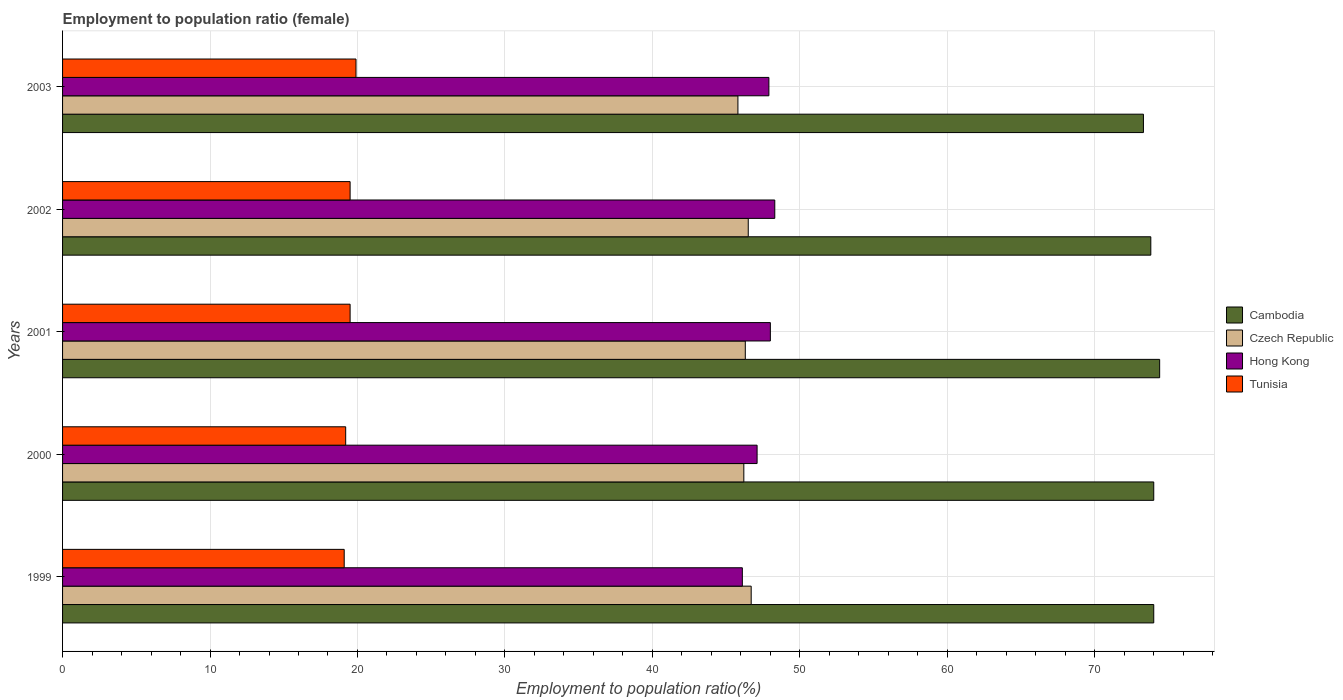How many different coloured bars are there?
Ensure brevity in your answer.  4. How many groups of bars are there?
Ensure brevity in your answer.  5. Are the number of bars per tick equal to the number of legend labels?
Provide a succinct answer. Yes. How many bars are there on the 3rd tick from the top?
Offer a very short reply. 4. In how many cases, is the number of bars for a given year not equal to the number of legend labels?
Offer a terse response. 0. What is the employment to population ratio in Czech Republic in 2000?
Make the answer very short. 46.2. Across all years, what is the maximum employment to population ratio in Tunisia?
Give a very brief answer. 19.9. Across all years, what is the minimum employment to population ratio in Hong Kong?
Ensure brevity in your answer.  46.1. What is the total employment to population ratio in Hong Kong in the graph?
Ensure brevity in your answer.  237.4. What is the difference between the employment to population ratio in Hong Kong in 2002 and that in 2003?
Ensure brevity in your answer.  0.4. What is the difference between the employment to population ratio in Cambodia in 2000 and the employment to population ratio in Czech Republic in 2003?
Your response must be concise. 28.2. What is the average employment to population ratio in Cambodia per year?
Your response must be concise. 73.9. In the year 2000, what is the difference between the employment to population ratio in Tunisia and employment to population ratio in Hong Kong?
Your response must be concise. -27.9. In how many years, is the employment to population ratio in Hong Kong greater than 12 %?
Your answer should be compact. 5. Is the employment to population ratio in Czech Republic in 2002 less than that in 2003?
Ensure brevity in your answer.  No. Is the difference between the employment to population ratio in Tunisia in 1999 and 2001 greater than the difference between the employment to population ratio in Hong Kong in 1999 and 2001?
Your response must be concise. Yes. What is the difference between the highest and the second highest employment to population ratio in Hong Kong?
Offer a very short reply. 0.3. What is the difference between the highest and the lowest employment to population ratio in Hong Kong?
Provide a succinct answer. 2.2. In how many years, is the employment to population ratio in Hong Kong greater than the average employment to population ratio in Hong Kong taken over all years?
Provide a succinct answer. 3. Is it the case that in every year, the sum of the employment to population ratio in Hong Kong and employment to population ratio in Tunisia is greater than the sum of employment to population ratio in Cambodia and employment to population ratio in Czech Republic?
Provide a short and direct response. No. What does the 1st bar from the top in 2002 represents?
Your answer should be compact. Tunisia. What does the 3rd bar from the bottom in 2001 represents?
Your answer should be very brief. Hong Kong. Are all the bars in the graph horizontal?
Ensure brevity in your answer.  Yes. How many years are there in the graph?
Offer a terse response. 5. Are the values on the major ticks of X-axis written in scientific E-notation?
Make the answer very short. No. Does the graph contain grids?
Offer a terse response. Yes. Where does the legend appear in the graph?
Give a very brief answer. Center right. What is the title of the graph?
Your answer should be compact. Employment to population ratio (female). Does "Cyprus" appear as one of the legend labels in the graph?
Offer a very short reply. No. What is the label or title of the X-axis?
Make the answer very short. Employment to population ratio(%). What is the Employment to population ratio(%) of Cambodia in 1999?
Ensure brevity in your answer.  74. What is the Employment to population ratio(%) in Czech Republic in 1999?
Provide a short and direct response. 46.7. What is the Employment to population ratio(%) in Hong Kong in 1999?
Your answer should be very brief. 46.1. What is the Employment to population ratio(%) of Tunisia in 1999?
Give a very brief answer. 19.1. What is the Employment to population ratio(%) in Czech Republic in 2000?
Ensure brevity in your answer.  46.2. What is the Employment to population ratio(%) of Hong Kong in 2000?
Give a very brief answer. 47.1. What is the Employment to population ratio(%) of Tunisia in 2000?
Your answer should be very brief. 19.2. What is the Employment to population ratio(%) in Cambodia in 2001?
Ensure brevity in your answer.  74.4. What is the Employment to population ratio(%) in Czech Republic in 2001?
Your response must be concise. 46.3. What is the Employment to population ratio(%) in Hong Kong in 2001?
Ensure brevity in your answer.  48. What is the Employment to population ratio(%) of Cambodia in 2002?
Offer a terse response. 73.8. What is the Employment to population ratio(%) of Czech Republic in 2002?
Provide a short and direct response. 46.5. What is the Employment to population ratio(%) of Hong Kong in 2002?
Offer a terse response. 48.3. What is the Employment to population ratio(%) in Cambodia in 2003?
Offer a very short reply. 73.3. What is the Employment to population ratio(%) in Czech Republic in 2003?
Make the answer very short. 45.8. What is the Employment to population ratio(%) in Hong Kong in 2003?
Your answer should be very brief. 47.9. What is the Employment to population ratio(%) of Tunisia in 2003?
Offer a very short reply. 19.9. Across all years, what is the maximum Employment to population ratio(%) in Cambodia?
Make the answer very short. 74.4. Across all years, what is the maximum Employment to population ratio(%) of Czech Republic?
Your response must be concise. 46.7. Across all years, what is the maximum Employment to population ratio(%) of Hong Kong?
Provide a short and direct response. 48.3. Across all years, what is the maximum Employment to population ratio(%) of Tunisia?
Give a very brief answer. 19.9. Across all years, what is the minimum Employment to population ratio(%) of Cambodia?
Provide a succinct answer. 73.3. Across all years, what is the minimum Employment to population ratio(%) of Czech Republic?
Your answer should be very brief. 45.8. Across all years, what is the minimum Employment to population ratio(%) in Hong Kong?
Give a very brief answer. 46.1. Across all years, what is the minimum Employment to population ratio(%) in Tunisia?
Give a very brief answer. 19.1. What is the total Employment to population ratio(%) of Cambodia in the graph?
Make the answer very short. 369.5. What is the total Employment to population ratio(%) in Czech Republic in the graph?
Offer a terse response. 231.5. What is the total Employment to population ratio(%) in Hong Kong in the graph?
Provide a succinct answer. 237.4. What is the total Employment to population ratio(%) of Tunisia in the graph?
Your answer should be compact. 97.2. What is the difference between the Employment to population ratio(%) of Czech Republic in 1999 and that in 2000?
Provide a succinct answer. 0.5. What is the difference between the Employment to population ratio(%) of Hong Kong in 1999 and that in 2000?
Keep it short and to the point. -1. What is the difference between the Employment to population ratio(%) of Cambodia in 1999 and that in 2001?
Your answer should be compact. -0.4. What is the difference between the Employment to population ratio(%) in Czech Republic in 1999 and that in 2001?
Your answer should be very brief. 0.4. What is the difference between the Employment to population ratio(%) in Tunisia in 1999 and that in 2001?
Offer a very short reply. -0.4. What is the difference between the Employment to population ratio(%) of Cambodia in 1999 and that in 2002?
Keep it short and to the point. 0.2. What is the difference between the Employment to population ratio(%) of Hong Kong in 1999 and that in 2002?
Keep it short and to the point. -2.2. What is the difference between the Employment to population ratio(%) in Hong Kong in 1999 and that in 2003?
Your answer should be compact. -1.8. What is the difference between the Employment to population ratio(%) of Cambodia in 2000 and that in 2001?
Make the answer very short. -0.4. What is the difference between the Employment to population ratio(%) of Hong Kong in 2000 and that in 2001?
Your answer should be very brief. -0.9. What is the difference between the Employment to population ratio(%) of Czech Republic in 2000 and that in 2002?
Your answer should be very brief. -0.3. What is the difference between the Employment to population ratio(%) of Hong Kong in 2000 and that in 2002?
Ensure brevity in your answer.  -1.2. What is the difference between the Employment to population ratio(%) of Tunisia in 2000 and that in 2002?
Your response must be concise. -0.3. What is the difference between the Employment to population ratio(%) in Cambodia in 2000 and that in 2003?
Make the answer very short. 0.7. What is the difference between the Employment to population ratio(%) of Hong Kong in 2000 and that in 2003?
Your answer should be very brief. -0.8. What is the difference between the Employment to population ratio(%) in Tunisia in 2000 and that in 2003?
Your response must be concise. -0.7. What is the difference between the Employment to population ratio(%) of Cambodia in 2001 and that in 2002?
Your answer should be compact. 0.6. What is the difference between the Employment to population ratio(%) in Hong Kong in 2001 and that in 2002?
Your response must be concise. -0.3. What is the difference between the Employment to population ratio(%) in Tunisia in 2001 and that in 2002?
Keep it short and to the point. 0. What is the difference between the Employment to population ratio(%) of Cambodia in 2001 and that in 2003?
Offer a very short reply. 1.1. What is the difference between the Employment to population ratio(%) of Czech Republic in 2001 and that in 2003?
Offer a terse response. 0.5. What is the difference between the Employment to population ratio(%) of Cambodia in 1999 and the Employment to population ratio(%) of Czech Republic in 2000?
Offer a terse response. 27.8. What is the difference between the Employment to population ratio(%) of Cambodia in 1999 and the Employment to population ratio(%) of Hong Kong in 2000?
Your response must be concise. 26.9. What is the difference between the Employment to population ratio(%) of Cambodia in 1999 and the Employment to population ratio(%) of Tunisia in 2000?
Give a very brief answer. 54.8. What is the difference between the Employment to population ratio(%) of Czech Republic in 1999 and the Employment to population ratio(%) of Hong Kong in 2000?
Give a very brief answer. -0.4. What is the difference between the Employment to population ratio(%) of Czech Republic in 1999 and the Employment to population ratio(%) of Tunisia in 2000?
Your answer should be very brief. 27.5. What is the difference between the Employment to population ratio(%) in Hong Kong in 1999 and the Employment to population ratio(%) in Tunisia in 2000?
Provide a succinct answer. 26.9. What is the difference between the Employment to population ratio(%) of Cambodia in 1999 and the Employment to population ratio(%) of Czech Republic in 2001?
Your answer should be compact. 27.7. What is the difference between the Employment to population ratio(%) of Cambodia in 1999 and the Employment to population ratio(%) of Hong Kong in 2001?
Offer a terse response. 26. What is the difference between the Employment to population ratio(%) in Cambodia in 1999 and the Employment to population ratio(%) in Tunisia in 2001?
Make the answer very short. 54.5. What is the difference between the Employment to population ratio(%) of Czech Republic in 1999 and the Employment to population ratio(%) of Tunisia in 2001?
Offer a terse response. 27.2. What is the difference between the Employment to population ratio(%) in Hong Kong in 1999 and the Employment to population ratio(%) in Tunisia in 2001?
Make the answer very short. 26.6. What is the difference between the Employment to population ratio(%) in Cambodia in 1999 and the Employment to population ratio(%) in Hong Kong in 2002?
Make the answer very short. 25.7. What is the difference between the Employment to population ratio(%) in Cambodia in 1999 and the Employment to population ratio(%) in Tunisia in 2002?
Give a very brief answer. 54.5. What is the difference between the Employment to population ratio(%) of Czech Republic in 1999 and the Employment to population ratio(%) of Hong Kong in 2002?
Offer a terse response. -1.6. What is the difference between the Employment to population ratio(%) in Czech Republic in 1999 and the Employment to population ratio(%) in Tunisia in 2002?
Offer a very short reply. 27.2. What is the difference between the Employment to population ratio(%) in Hong Kong in 1999 and the Employment to population ratio(%) in Tunisia in 2002?
Offer a very short reply. 26.6. What is the difference between the Employment to population ratio(%) in Cambodia in 1999 and the Employment to population ratio(%) in Czech Republic in 2003?
Ensure brevity in your answer.  28.2. What is the difference between the Employment to population ratio(%) of Cambodia in 1999 and the Employment to population ratio(%) of Hong Kong in 2003?
Provide a succinct answer. 26.1. What is the difference between the Employment to population ratio(%) of Cambodia in 1999 and the Employment to population ratio(%) of Tunisia in 2003?
Provide a succinct answer. 54.1. What is the difference between the Employment to population ratio(%) of Czech Republic in 1999 and the Employment to population ratio(%) of Hong Kong in 2003?
Provide a succinct answer. -1.2. What is the difference between the Employment to population ratio(%) of Czech Republic in 1999 and the Employment to population ratio(%) of Tunisia in 2003?
Offer a terse response. 26.8. What is the difference between the Employment to population ratio(%) in Hong Kong in 1999 and the Employment to population ratio(%) in Tunisia in 2003?
Your answer should be compact. 26.2. What is the difference between the Employment to population ratio(%) of Cambodia in 2000 and the Employment to population ratio(%) of Czech Republic in 2001?
Your answer should be very brief. 27.7. What is the difference between the Employment to population ratio(%) of Cambodia in 2000 and the Employment to population ratio(%) of Tunisia in 2001?
Make the answer very short. 54.5. What is the difference between the Employment to population ratio(%) in Czech Republic in 2000 and the Employment to population ratio(%) in Hong Kong in 2001?
Provide a short and direct response. -1.8. What is the difference between the Employment to population ratio(%) in Czech Republic in 2000 and the Employment to population ratio(%) in Tunisia in 2001?
Your response must be concise. 26.7. What is the difference between the Employment to population ratio(%) of Hong Kong in 2000 and the Employment to population ratio(%) of Tunisia in 2001?
Your answer should be compact. 27.6. What is the difference between the Employment to population ratio(%) in Cambodia in 2000 and the Employment to population ratio(%) in Hong Kong in 2002?
Offer a very short reply. 25.7. What is the difference between the Employment to population ratio(%) of Cambodia in 2000 and the Employment to population ratio(%) of Tunisia in 2002?
Offer a very short reply. 54.5. What is the difference between the Employment to population ratio(%) in Czech Republic in 2000 and the Employment to population ratio(%) in Hong Kong in 2002?
Provide a succinct answer. -2.1. What is the difference between the Employment to population ratio(%) in Czech Republic in 2000 and the Employment to population ratio(%) in Tunisia in 2002?
Keep it short and to the point. 26.7. What is the difference between the Employment to population ratio(%) in Hong Kong in 2000 and the Employment to population ratio(%) in Tunisia in 2002?
Keep it short and to the point. 27.6. What is the difference between the Employment to population ratio(%) of Cambodia in 2000 and the Employment to population ratio(%) of Czech Republic in 2003?
Offer a very short reply. 28.2. What is the difference between the Employment to population ratio(%) in Cambodia in 2000 and the Employment to population ratio(%) in Hong Kong in 2003?
Your answer should be compact. 26.1. What is the difference between the Employment to population ratio(%) of Cambodia in 2000 and the Employment to population ratio(%) of Tunisia in 2003?
Your response must be concise. 54.1. What is the difference between the Employment to population ratio(%) of Czech Republic in 2000 and the Employment to population ratio(%) of Tunisia in 2003?
Your response must be concise. 26.3. What is the difference between the Employment to population ratio(%) in Hong Kong in 2000 and the Employment to population ratio(%) in Tunisia in 2003?
Ensure brevity in your answer.  27.2. What is the difference between the Employment to population ratio(%) of Cambodia in 2001 and the Employment to population ratio(%) of Czech Republic in 2002?
Ensure brevity in your answer.  27.9. What is the difference between the Employment to population ratio(%) in Cambodia in 2001 and the Employment to population ratio(%) in Hong Kong in 2002?
Offer a very short reply. 26.1. What is the difference between the Employment to population ratio(%) in Cambodia in 2001 and the Employment to population ratio(%) in Tunisia in 2002?
Make the answer very short. 54.9. What is the difference between the Employment to population ratio(%) of Czech Republic in 2001 and the Employment to population ratio(%) of Tunisia in 2002?
Provide a succinct answer. 26.8. What is the difference between the Employment to population ratio(%) of Hong Kong in 2001 and the Employment to population ratio(%) of Tunisia in 2002?
Offer a terse response. 28.5. What is the difference between the Employment to population ratio(%) of Cambodia in 2001 and the Employment to population ratio(%) of Czech Republic in 2003?
Provide a succinct answer. 28.6. What is the difference between the Employment to population ratio(%) of Cambodia in 2001 and the Employment to population ratio(%) of Tunisia in 2003?
Your answer should be very brief. 54.5. What is the difference between the Employment to population ratio(%) of Czech Republic in 2001 and the Employment to population ratio(%) of Tunisia in 2003?
Provide a short and direct response. 26.4. What is the difference between the Employment to population ratio(%) in Hong Kong in 2001 and the Employment to population ratio(%) in Tunisia in 2003?
Ensure brevity in your answer.  28.1. What is the difference between the Employment to population ratio(%) in Cambodia in 2002 and the Employment to population ratio(%) in Hong Kong in 2003?
Give a very brief answer. 25.9. What is the difference between the Employment to population ratio(%) of Cambodia in 2002 and the Employment to population ratio(%) of Tunisia in 2003?
Keep it short and to the point. 53.9. What is the difference between the Employment to population ratio(%) in Czech Republic in 2002 and the Employment to population ratio(%) in Tunisia in 2003?
Provide a succinct answer. 26.6. What is the difference between the Employment to population ratio(%) in Hong Kong in 2002 and the Employment to population ratio(%) in Tunisia in 2003?
Give a very brief answer. 28.4. What is the average Employment to population ratio(%) of Cambodia per year?
Provide a succinct answer. 73.9. What is the average Employment to population ratio(%) in Czech Republic per year?
Provide a succinct answer. 46.3. What is the average Employment to population ratio(%) in Hong Kong per year?
Give a very brief answer. 47.48. What is the average Employment to population ratio(%) of Tunisia per year?
Your answer should be compact. 19.44. In the year 1999, what is the difference between the Employment to population ratio(%) of Cambodia and Employment to population ratio(%) of Czech Republic?
Your answer should be compact. 27.3. In the year 1999, what is the difference between the Employment to population ratio(%) of Cambodia and Employment to population ratio(%) of Hong Kong?
Offer a very short reply. 27.9. In the year 1999, what is the difference between the Employment to population ratio(%) in Cambodia and Employment to population ratio(%) in Tunisia?
Give a very brief answer. 54.9. In the year 1999, what is the difference between the Employment to population ratio(%) in Czech Republic and Employment to population ratio(%) in Hong Kong?
Provide a short and direct response. 0.6. In the year 1999, what is the difference between the Employment to population ratio(%) of Czech Republic and Employment to population ratio(%) of Tunisia?
Your answer should be very brief. 27.6. In the year 2000, what is the difference between the Employment to population ratio(%) of Cambodia and Employment to population ratio(%) of Czech Republic?
Provide a short and direct response. 27.8. In the year 2000, what is the difference between the Employment to population ratio(%) of Cambodia and Employment to population ratio(%) of Hong Kong?
Ensure brevity in your answer.  26.9. In the year 2000, what is the difference between the Employment to population ratio(%) of Cambodia and Employment to population ratio(%) of Tunisia?
Provide a succinct answer. 54.8. In the year 2000, what is the difference between the Employment to population ratio(%) in Czech Republic and Employment to population ratio(%) in Hong Kong?
Offer a terse response. -0.9. In the year 2000, what is the difference between the Employment to population ratio(%) in Hong Kong and Employment to population ratio(%) in Tunisia?
Your answer should be compact. 27.9. In the year 2001, what is the difference between the Employment to population ratio(%) of Cambodia and Employment to population ratio(%) of Czech Republic?
Offer a very short reply. 28.1. In the year 2001, what is the difference between the Employment to population ratio(%) of Cambodia and Employment to population ratio(%) of Hong Kong?
Provide a short and direct response. 26.4. In the year 2001, what is the difference between the Employment to population ratio(%) in Cambodia and Employment to population ratio(%) in Tunisia?
Your answer should be very brief. 54.9. In the year 2001, what is the difference between the Employment to population ratio(%) of Czech Republic and Employment to population ratio(%) of Hong Kong?
Your answer should be very brief. -1.7. In the year 2001, what is the difference between the Employment to population ratio(%) in Czech Republic and Employment to population ratio(%) in Tunisia?
Make the answer very short. 26.8. In the year 2001, what is the difference between the Employment to population ratio(%) of Hong Kong and Employment to population ratio(%) of Tunisia?
Make the answer very short. 28.5. In the year 2002, what is the difference between the Employment to population ratio(%) of Cambodia and Employment to population ratio(%) of Czech Republic?
Your response must be concise. 27.3. In the year 2002, what is the difference between the Employment to population ratio(%) of Cambodia and Employment to population ratio(%) of Tunisia?
Provide a short and direct response. 54.3. In the year 2002, what is the difference between the Employment to population ratio(%) in Hong Kong and Employment to population ratio(%) in Tunisia?
Offer a very short reply. 28.8. In the year 2003, what is the difference between the Employment to population ratio(%) in Cambodia and Employment to population ratio(%) in Hong Kong?
Make the answer very short. 25.4. In the year 2003, what is the difference between the Employment to population ratio(%) in Cambodia and Employment to population ratio(%) in Tunisia?
Offer a very short reply. 53.4. In the year 2003, what is the difference between the Employment to population ratio(%) in Czech Republic and Employment to population ratio(%) in Hong Kong?
Your response must be concise. -2.1. In the year 2003, what is the difference between the Employment to population ratio(%) of Czech Republic and Employment to population ratio(%) of Tunisia?
Your response must be concise. 25.9. What is the ratio of the Employment to population ratio(%) of Czech Republic in 1999 to that in 2000?
Offer a very short reply. 1.01. What is the ratio of the Employment to population ratio(%) in Hong Kong in 1999 to that in 2000?
Give a very brief answer. 0.98. What is the ratio of the Employment to population ratio(%) of Czech Republic in 1999 to that in 2001?
Keep it short and to the point. 1.01. What is the ratio of the Employment to population ratio(%) of Hong Kong in 1999 to that in 2001?
Give a very brief answer. 0.96. What is the ratio of the Employment to population ratio(%) of Tunisia in 1999 to that in 2001?
Your answer should be compact. 0.98. What is the ratio of the Employment to population ratio(%) in Czech Republic in 1999 to that in 2002?
Provide a short and direct response. 1. What is the ratio of the Employment to population ratio(%) of Hong Kong in 1999 to that in 2002?
Offer a very short reply. 0.95. What is the ratio of the Employment to population ratio(%) in Tunisia in 1999 to that in 2002?
Your answer should be compact. 0.98. What is the ratio of the Employment to population ratio(%) in Cambodia in 1999 to that in 2003?
Offer a terse response. 1.01. What is the ratio of the Employment to population ratio(%) of Czech Republic in 1999 to that in 2003?
Your answer should be compact. 1.02. What is the ratio of the Employment to population ratio(%) of Hong Kong in 1999 to that in 2003?
Ensure brevity in your answer.  0.96. What is the ratio of the Employment to population ratio(%) of Tunisia in 1999 to that in 2003?
Provide a succinct answer. 0.96. What is the ratio of the Employment to population ratio(%) in Cambodia in 2000 to that in 2001?
Make the answer very short. 0.99. What is the ratio of the Employment to population ratio(%) of Czech Republic in 2000 to that in 2001?
Your response must be concise. 1. What is the ratio of the Employment to population ratio(%) of Hong Kong in 2000 to that in 2001?
Your answer should be very brief. 0.98. What is the ratio of the Employment to population ratio(%) in Tunisia in 2000 to that in 2001?
Ensure brevity in your answer.  0.98. What is the ratio of the Employment to population ratio(%) in Cambodia in 2000 to that in 2002?
Your response must be concise. 1. What is the ratio of the Employment to population ratio(%) of Hong Kong in 2000 to that in 2002?
Keep it short and to the point. 0.98. What is the ratio of the Employment to population ratio(%) in Tunisia in 2000 to that in 2002?
Keep it short and to the point. 0.98. What is the ratio of the Employment to population ratio(%) in Cambodia in 2000 to that in 2003?
Offer a terse response. 1.01. What is the ratio of the Employment to population ratio(%) in Czech Republic in 2000 to that in 2003?
Make the answer very short. 1.01. What is the ratio of the Employment to population ratio(%) in Hong Kong in 2000 to that in 2003?
Provide a short and direct response. 0.98. What is the ratio of the Employment to population ratio(%) in Tunisia in 2000 to that in 2003?
Your answer should be compact. 0.96. What is the ratio of the Employment to population ratio(%) of Cambodia in 2001 to that in 2003?
Make the answer very short. 1.01. What is the ratio of the Employment to population ratio(%) in Czech Republic in 2001 to that in 2003?
Your answer should be compact. 1.01. What is the ratio of the Employment to population ratio(%) in Hong Kong in 2001 to that in 2003?
Your answer should be very brief. 1. What is the ratio of the Employment to population ratio(%) in Tunisia in 2001 to that in 2003?
Provide a short and direct response. 0.98. What is the ratio of the Employment to population ratio(%) in Cambodia in 2002 to that in 2003?
Offer a very short reply. 1.01. What is the ratio of the Employment to population ratio(%) in Czech Republic in 2002 to that in 2003?
Your answer should be compact. 1.02. What is the ratio of the Employment to population ratio(%) in Hong Kong in 2002 to that in 2003?
Give a very brief answer. 1.01. What is the ratio of the Employment to population ratio(%) of Tunisia in 2002 to that in 2003?
Offer a terse response. 0.98. What is the difference between the highest and the second highest Employment to population ratio(%) of Cambodia?
Your answer should be compact. 0.4. What is the difference between the highest and the second highest Employment to population ratio(%) of Czech Republic?
Offer a very short reply. 0.2. What is the difference between the highest and the second highest Employment to population ratio(%) of Hong Kong?
Provide a succinct answer. 0.3. What is the difference between the highest and the lowest Employment to population ratio(%) in Cambodia?
Your response must be concise. 1.1. What is the difference between the highest and the lowest Employment to population ratio(%) of Hong Kong?
Your answer should be compact. 2.2. 